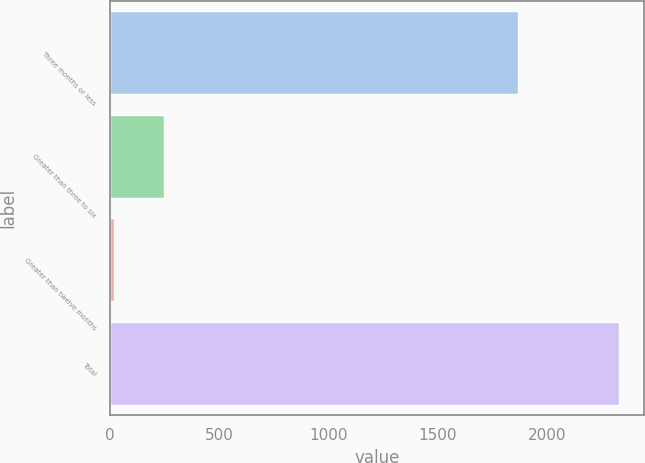<chart> <loc_0><loc_0><loc_500><loc_500><bar_chart><fcel>Three months or less<fcel>Greater than three to six<fcel>Greater than twelve months<fcel>Total<nl><fcel>1865<fcel>249<fcel>18<fcel>2328<nl></chart> 